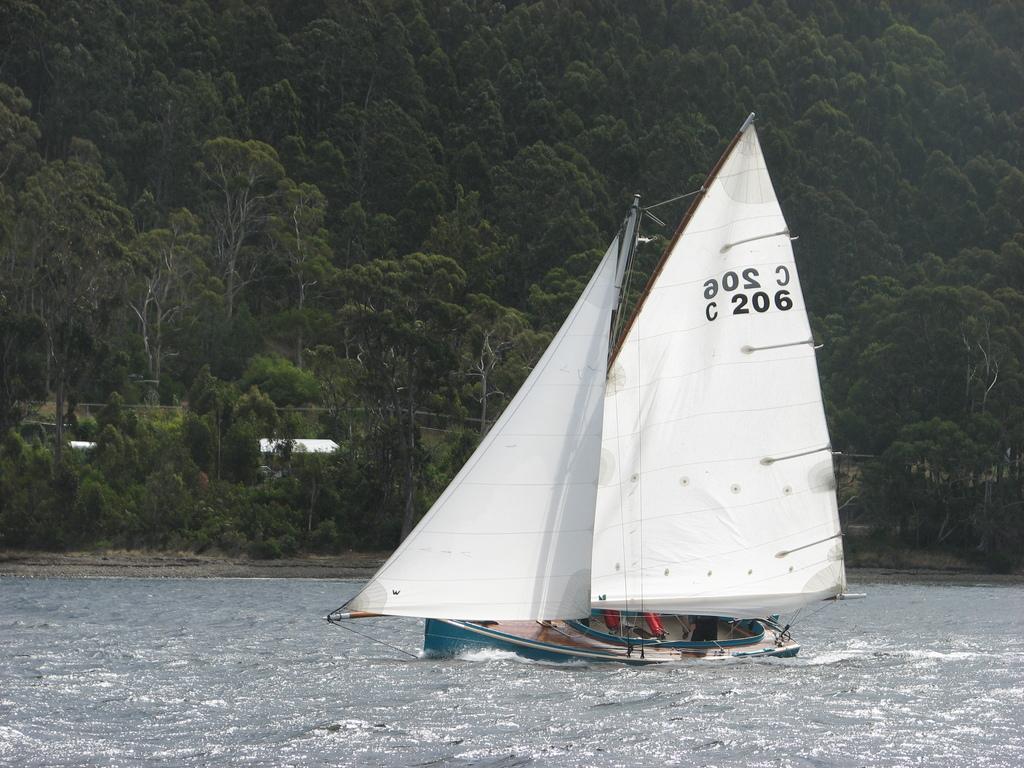Describe this image in one or two sentences. In this picture there is a boat which is on the water and there are two white color objects above it and there are trees in the background. 